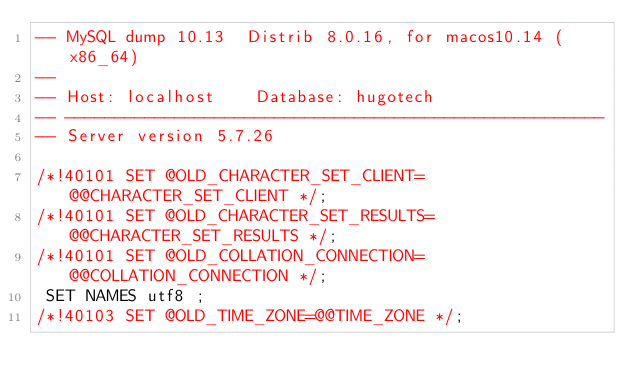<code> <loc_0><loc_0><loc_500><loc_500><_SQL_>-- MySQL dump 10.13  Distrib 8.0.16, for macos10.14 (x86_64)
--
-- Host: localhost    Database: hugotech
-- ------------------------------------------------------
-- Server version	5.7.26

/*!40101 SET @OLD_CHARACTER_SET_CLIENT=@@CHARACTER_SET_CLIENT */;
/*!40101 SET @OLD_CHARACTER_SET_RESULTS=@@CHARACTER_SET_RESULTS */;
/*!40101 SET @OLD_COLLATION_CONNECTION=@@COLLATION_CONNECTION */;
 SET NAMES utf8 ;
/*!40103 SET @OLD_TIME_ZONE=@@TIME_ZONE */;</code> 